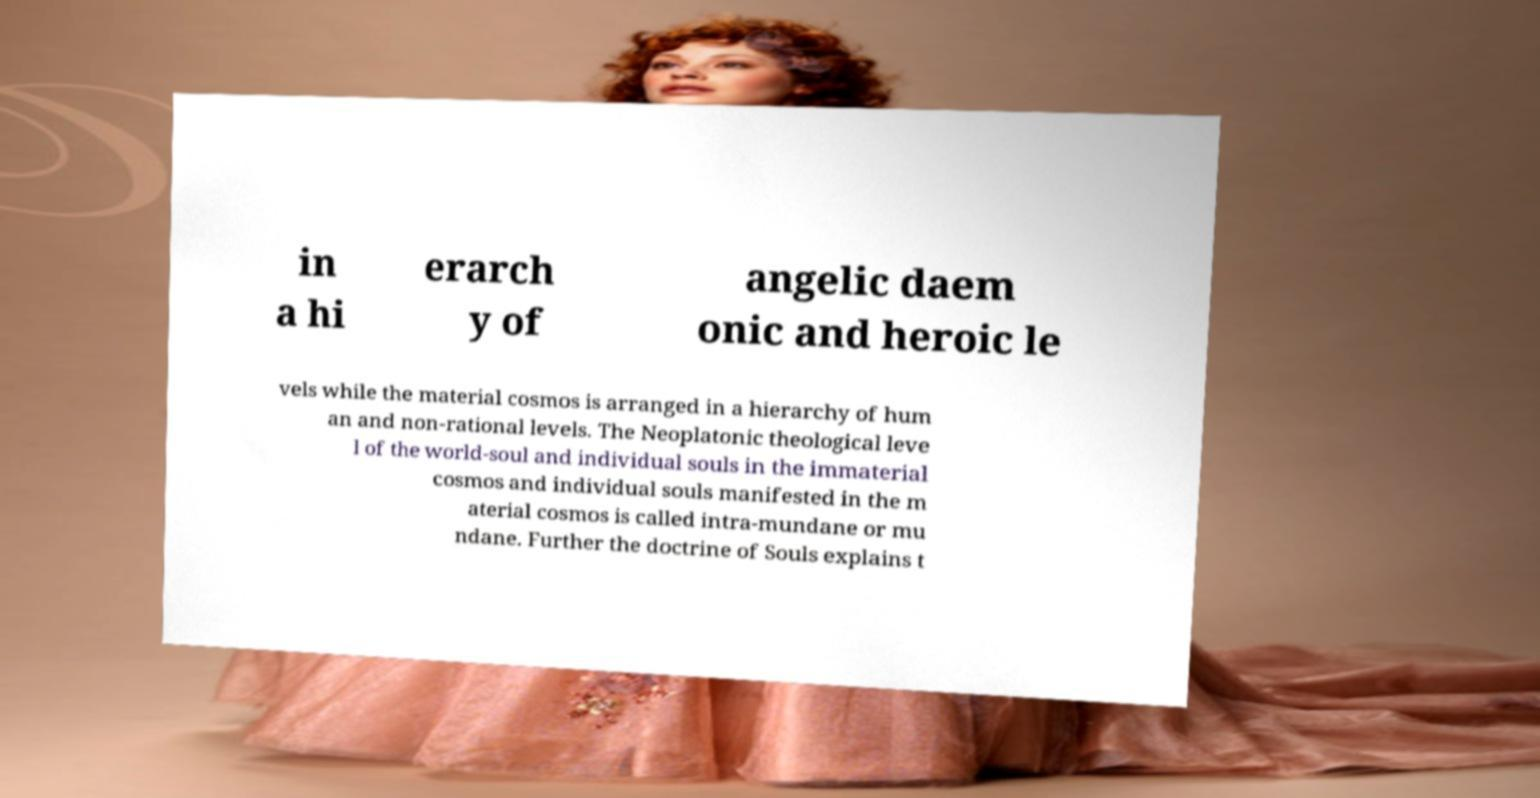Please read and relay the text visible in this image. What does it say? in a hi erarch y of angelic daem onic and heroic le vels while the material cosmos is arranged in a hierarchy of hum an and non-rational levels. The Neoplatonic theological leve l of the world-soul and individual souls in the immaterial cosmos and individual souls manifested in the m aterial cosmos is called intra-mundane or mu ndane. Further the doctrine of Souls explains t 